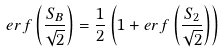<formula> <loc_0><loc_0><loc_500><loc_500>e r f \left ( \frac { S _ { B } } { \sqrt { 2 } } \right ) = \frac { 1 } { 2 } \left ( 1 + e r f \left ( \frac { S _ { 2 } } { \sqrt { 2 } } \right ) \right )</formula> 